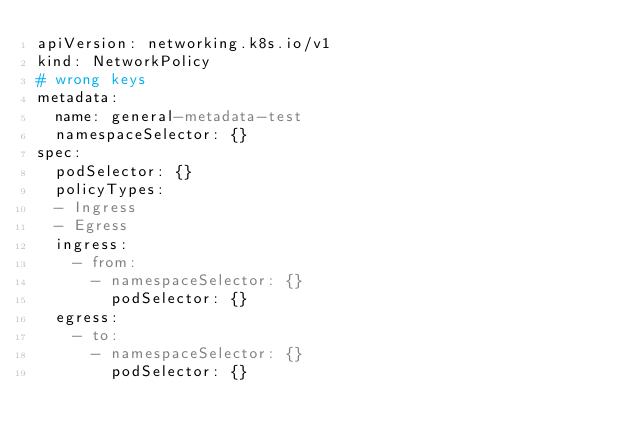<code> <loc_0><loc_0><loc_500><loc_500><_YAML_>apiVersion: networking.k8s.io/v1
kind: NetworkPolicy
# wrong keys
metadata:
  name: general-metadata-test
  namespaceSelector: {}
spec:
  podSelector: {}
  policyTypes:
  - Ingress
  - Egress
  ingress:
    - from:
      - namespaceSelector: {}
        podSelector: {}
  egress:
    - to:
      - namespaceSelector: {}
        podSelector: {}</code> 